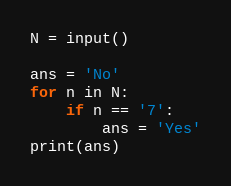<code> <loc_0><loc_0><loc_500><loc_500><_Python_>N = input()

ans = 'No'
for n in N:
    if n == '7':
        ans = 'Yes'
print(ans)

</code> 